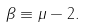<formula> <loc_0><loc_0><loc_500><loc_500>\beta \equiv \mu - 2 .</formula> 